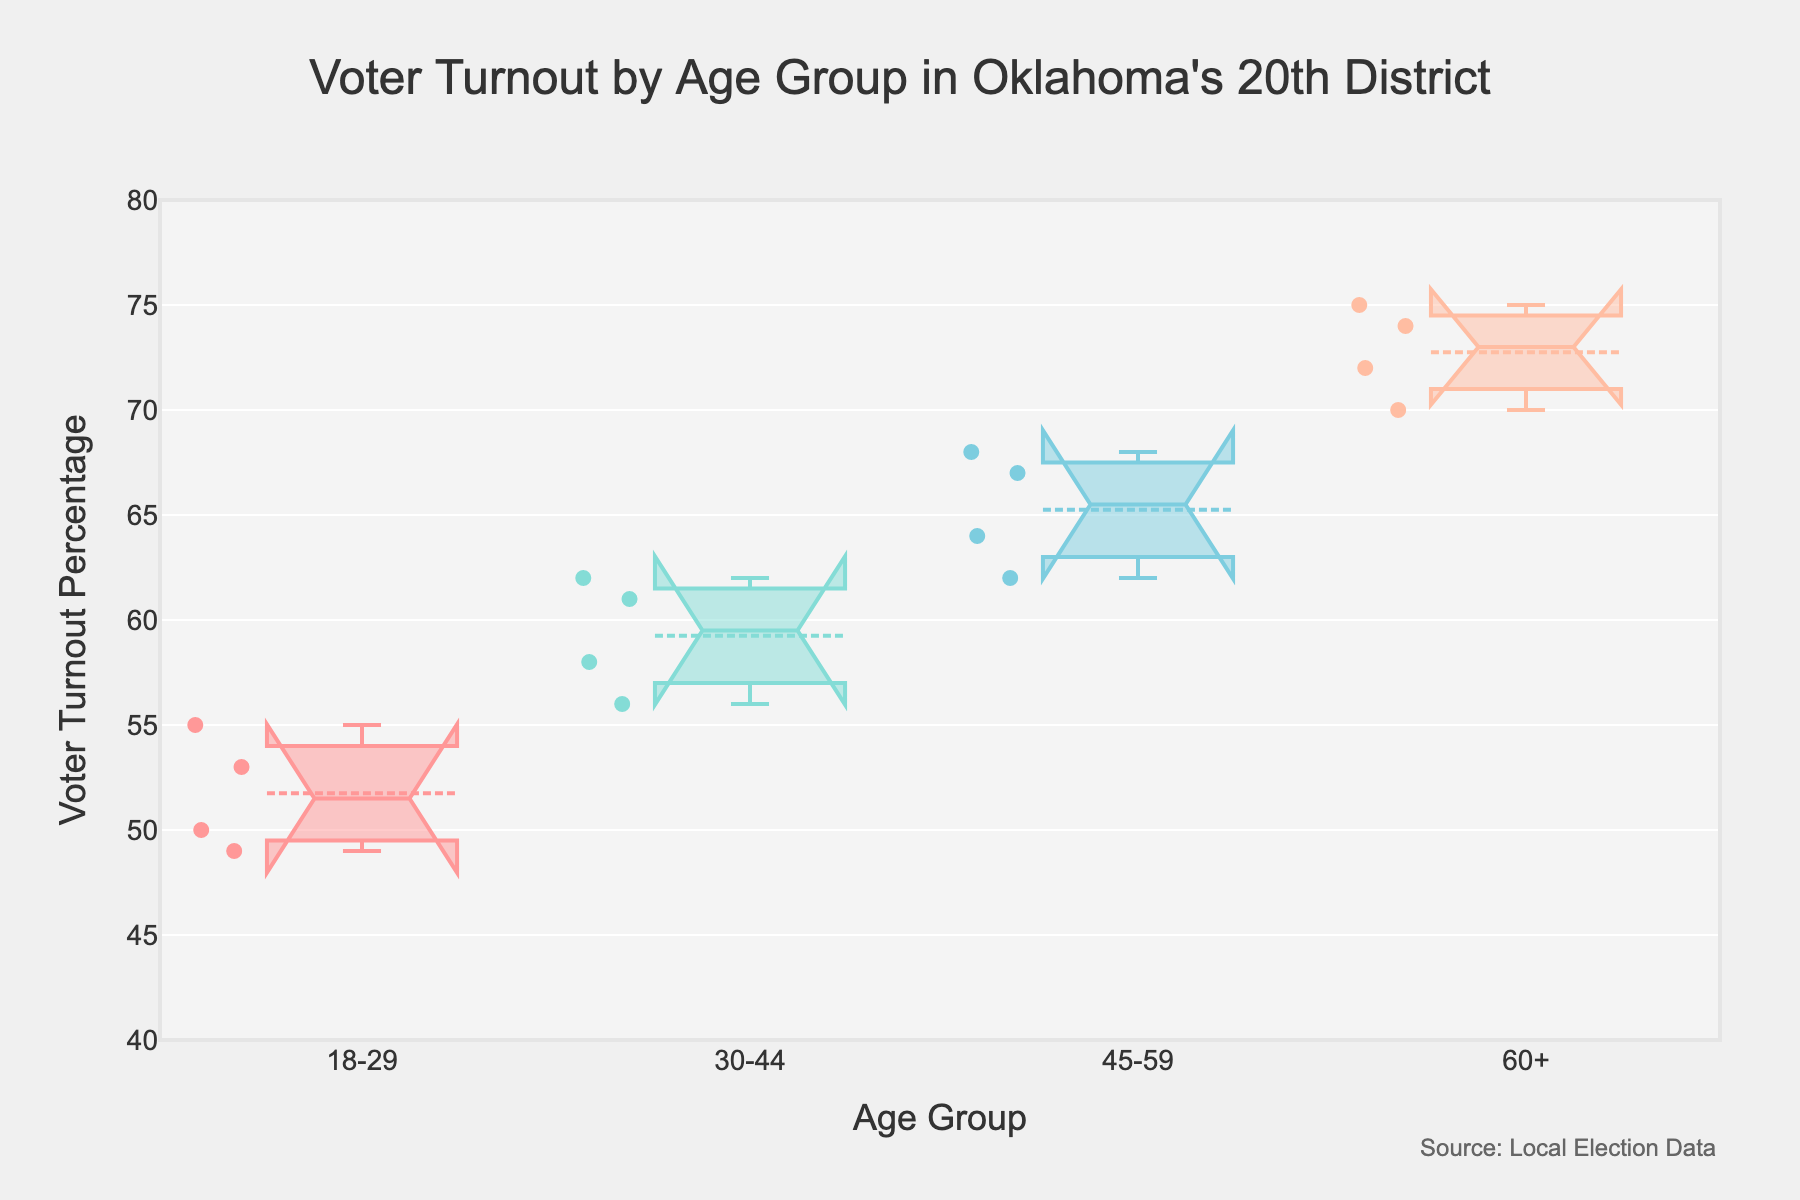what is the title of the plot? The title is typically placed at the top of the plot. Observing the top of the plot, we see the title is given.
Answer: Voter Turnout by Age Group in Oklahoma's 20th District which age group has the highest median voter turnout percentage? By observing the central line in the notched box plots for each age group on the vertical axis, we can identify the age group with the highest median voter turnout. The 60+ age group has the highest central line.
Answer: 60+ what is the median voter turnout percentage for the 18-29 age group? By looking at the center notch of the notched box plot for the 18-29 age group, we see the median value denoted by the central horizontal line.
Answer: 52 which election year showed the most significant difference in voter turnout percentage between the 18-29 and 60+ age groups? Examine the vertical spread between the notches of the 18-29 and 60+ age groups for each election year. The year with the largest notch spread represents the most significant difference. The year 2018 shows the most significant difference.
Answer: 2018 are the voter turnout percentages for the 60+ age group generally higher than those of the 18-29 age group? Comparing the notched box plots for the 60+ and 18-29 age groups, one should see if the values in the 60+ box plot are generally higher than those in the 18-29 box plot. Yes, the 60+ voter turnout percentages are generally higher.
Answer: Yes which age group has the smallest interquartile range (IQR) of voter turnout percentages? The IQR is determined by the vertical height of the box in the notched box plot. The smallest IQR corresponds to the shortest box height. The 30-44 age group has the smallest IQR.
Answer: 30-44 how many age groups are compared in the plot? The number of unique box plots represents the number of age groups being compared. The plot shows four unique notched box plots.
Answer: 4 which age group shows the most variability in voter turnout percentage? Variability is represented by the total range covered by each notched box plot. The age group with the tallest box and whiskers denotes the greatest variability. The 18-29 age group shows the most variability.
Answer: 18-29 is there an overlap in the 95% confidence intervals for the medians of any age groups? Overlap of notches in the box plots implies overlapping 95% confidence intervals for medians. Both the 30-44 and the 45-59 age groups show overlapping notches.
Answer: Yes which age group had a higher minimum voter turnout percentage in 2014? Locate the minimum points (bottom whisker) for the 2014 dataset of each age group’s box plot. Comparing the minimum levels, the 60+ age group had a higher minimum.
Answer: 60+ 